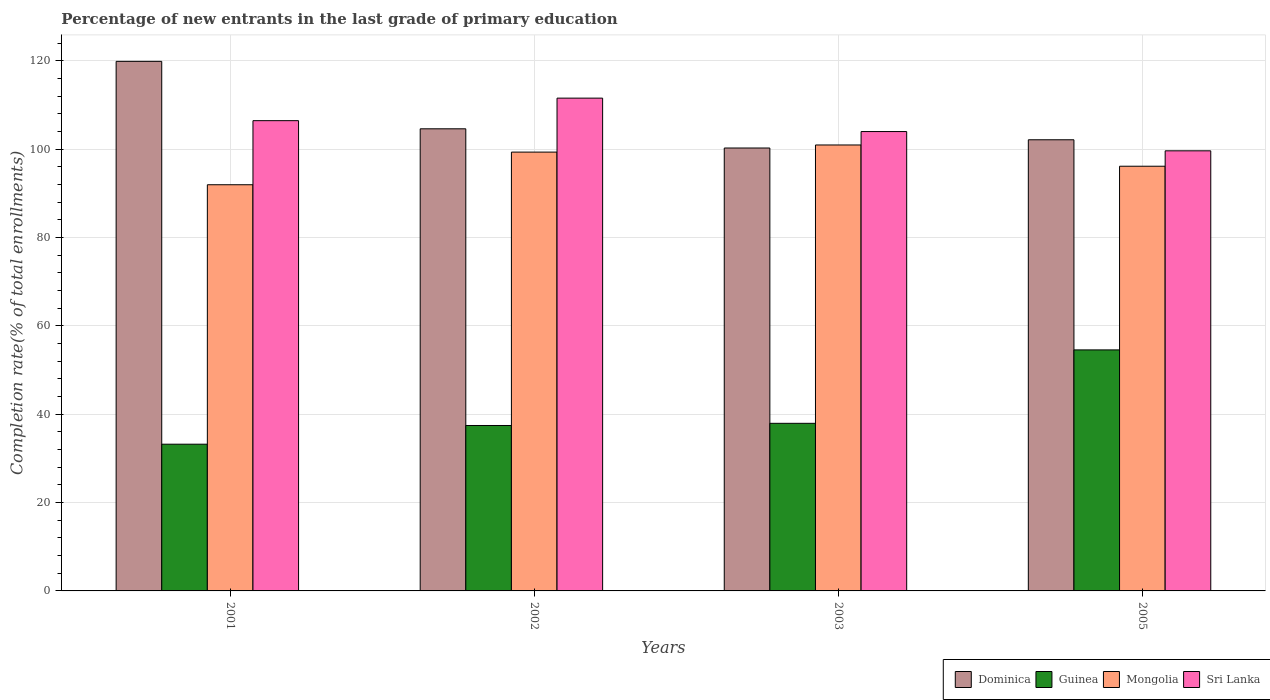How many groups of bars are there?
Offer a very short reply. 4. Are the number of bars on each tick of the X-axis equal?
Provide a succinct answer. Yes. In how many cases, is the number of bars for a given year not equal to the number of legend labels?
Your response must be concise. 0. What is the percentage of new entrants in Sri Lanka in 2002?
Provide a succinct answer. 111.57. Across all years, what is the maximum percentage of new entrants in Sri Lanka?
Offer a very short reply. 111.57. Across all years, what is the minimum percentage of new entrants in Mongolia?
Offer a very short reply. 91.96. In which year was the percentage of new entrants in Sri Lanka minimum?
Your response must be concise. 2005. What is the total percentage of new entrants in Guinea in the graph?
Provide a succinct answer. 163.19. What is the difference between the percentage of new entrants in Guinea in 2003 and that in 2005?
Ensure brevity in your answer.  -16.62. What is the difference between the percentage of new entrants in Mongolia in 2003 and the percentage of new entrants in Dominica in 2001?
Keep it short and to the point. -18.93. What is the average percentage of new entrants in Guinea per year?
Your answer should be compact. 40.8. In the year 2003, what is the difference between the percentage of new entrants in Guinea and percentage of new entrants in Dominica?
Offer a terse response. -62.33. What is the ratio of the percentage of new entrants in Dominica in 2001 to that in 2003?
Offer a terse response. 1.2. Is the percentage of new entrants in Sri Lanka in 2001 less than that in 2005?
Make the answer very short. No. What is the difference between the highest and the second highest percentage of new entrants in Dominica?
Your response must be concise. 15.27. What is the difference between the highest and the lowest percentage of new entrants in Sri Lanka?
Offer a very short reply. 11.93. Is the sum of the percentage of new entrants in Sri Lanka in 2001 and 2002 greater than the maximum percentage of new entrants in Dominica across all years?
Offer a very short reply. Yes. Is it the case that in every year, the sum of the percentage of new entrants in Mongolia and percentage of new entrants in Sri Lanka is greater than the sum of percentage of new entrants in Guinea and percentage of new entrants in Dominica?
Make the answer very short. No. What does the 2nd bar from the left in 2001 represents?
Keep it short and to the point. Guinea. What does the 2nd bar from the right in 2001 represents?
Your answer should be very brief. Mongolia. How many years are there in the graph?
Offer a terse response. 4. Are the values on the major ticks of Y-axis written in scientific E-notation?
Your response must be concise. No. Does the graph contain any zero values?
Provide a succinct answer. No. Where does the legend appear in the graph?
Make the answer very short. Bottom right. How many legend labels are there?
Your answer should be compact. 4. How are the legend labels stacked?
Offer a very short reply. Horizontal. What is the title of the graph?
Offer a terse response. Percentage of new entrants in the last grade of primary education. What is the label or title of the Y-axis?
Ensure brevity in your answer.  Completion rate(% of total enrollments). What is the Completion rate(% of total enrollments) in Dominica in 2001?
Provide a short and direct response. 119.9. What is the Completion rate(% of total enrollments) in Guinea in 2001?
Offer a very short reply. 33.22. What is the Completion rate(% of total enrollments) of Mongolia in 2001?
Your answer should be compact. 91.96. What is the Completion rate(% of total enrollments) of Sri Lanka in 2001?
Your answer should be compact. 106.47. What is the Completion rate(% of total enrollments) of Dominica in 2002?
Provide a short and direct response. 104.63. What is the Completion rate(% of total enrollments) in Guinea in 2002?
Offer a very short reply. 37.46. What is the Completion rate(% of total enrollments) in Mongolia in 2002?
Provide a succinct answer. 99.35. What is the Completion rate(% of total enrollments) of Sri Lanka in 2002?
Make the answer very short. 111.57. What is the Completion rate(% of total enrollments) of Dominica in 2003?
Your response must be concise. 100.28. What is the Completion rate(% of total enrollments) of Guinea in 2003?
Provide a succinct answer. 37.94. What is the Completion rate(% of total enrollments) in Mongolia in 2003?
Keep it short and to the point. 100.96. What is the Completion rate(% of total enrollments) of Sri Lanka in 2003?
Keep it short and to the point. 104. What is the Completion rate(% of total enrollments) in Dominica in 2005?
Your answer should be compact. 102.14. What is the Completion rate(% of total enrollments) in Guinea in 2005?
Provide a succinct answer. 54.57. What is the Completion rate(% of total enrollments) of Mongolia in 2005?
Keep it short and to the point. 96.15. What is the Completion rate(% of total enrollments) in Sri Lanka in 2005?
Offer a very short reply. 99.64. Across all years, what is the maximum Completion rate(% of total enrollments) in Dominica?
Your answer should be very brief. 119.9. Across all years, what is the maximum Completion rate(% of total enrollments) in Guinea?
Provide a succinct answer. 54.57. Across all years, what is the maximum Completion rate(% of total enrollments) of Mongolia?
Offer a very short reply. 100.96. Across all years, what is the maximum Completion rate(% of total enrollments) in Sri Lanka?
Provide a succinct answer. 111.57. Across all years, what is the minimum Completion rate(% of total enrollments) in Dominica?
Make the answer very short. 100.28. Across all years, what is the minimum Completion rate(% of total enrollments) of Guinea?
Offer a very short reply. 33.22. Across all years, what is the minimum Completion rate(% of total enrollments) of Mongolia?
Keep it short and to the point. 91.96. Across all years, what is the minimum Completion rate(% of total enrollments) of Sri Lanka?
Make the answer very short. 99.64. What is the total Completion rate(% of total enrollments) in Dominica in the graph?
Provide a succinct answer. 426.94. What is the total Completion rate(% of total enrollments) in Guinea in the graph?
Offer a terse response. 163.19. What is the total Completion rate(% of total enrollments) of Mongolia in the graph?
Provide a succinct answer. 388.43. What is the total Completion rate(% of total enrollments) of Sri Lanka in the graph?
Offer a very short reply. 421.68. What is the difference between the Completion rate(% of total enrollments) of Dominica in 2001 and that in 2002?
Your response must be concise. 15.27. What is the difference between the Completion rate(% of total enrollments) in Guinea in 2001 and that in 2002?
Provide a short and direct response. -4.23. What is the difference between the Completion rate(% of total enrollments) of Mongolia in 2001 and that in 2002?
Keep it short and to the point. -7.39. What is the difference between the Completion rate(% of total enrollments) of Sri Lanka in 2001 and that in 2002?
Offer a very short reply. -5.1. What is the difference between the Completion rate(% of total enrollments) of Dominica in 2001 and that in 2003?
Offer a terse response. 19.62. What is the difference between the Completion rate(% of total enrollments) of Guinea in 2001 and that in 2003?
Offer a very short reply. -4.72. What is the difference between the Completion rate(% of total enrollments) in Mongolia in 2001 and that in 2003?
Keep it short and to the point. -9. What is the difference between the Completion rate(% of total enrollments) in Sri Lanka in 2001 and that in 2003?
Offer a terse response. 2.47. What is the difference between the Completion rate(% of total enrollments) in Dominica in 2001 and that in 2005?
Give a very brief answer. 17.75. What is the difference between the Completion rate(% of total enrollments) in Guinea in 2001 and that in 2005?
Offer a very short reply. -21.35. What is the difference between the Completion rate(% of total enrollments) in Mongolia in 2001 and that in 2005?
Your answer should be compact. -4.19. What is the difference between the Completion rate(% of total enrollments) of Sri Lanka in 2001 and that in 2005?
Your answer should be very brief. 6.83. What is the difference between the Completion rate(% of total enrollments) of Dominica in 2002 and that in 2003?
Your answer should be compact. 4.35. What is the difference between the Completion rate(% of total enrollments) in Guinea in 2002 and that in 2003?
Offer a very short reply. -0.49. What is the difference between the Completion rate(% of total enrollments) in Mongolia in 2002 and that in 2003?
Your answer should be compact. -1.61. What is the difference between the Completion rate(% of total enrollments) in Sri Lanka in 2002 and that in 2003?
Your response must be concise. 7.57. What is the difference between the Completion rate(% of total enrollments) in Dominica in 2002 and that in 2005?
Give a very brief answer. 2.48. What is the difference between the Completion rate(% of total enrollments) in Guinea in 2002 and that in 2005?
Your answer should be very brief. -17.11. What is the difference between the Completion rate(% of total enrollments) in Mongolia in 2002 and that in 2005?
Your response must be concise. 3.2. What is the difference between the Completion rate(% of total enrollments) in Sri Lanka in 2002 and that in 2005?
Give a very brief answer. 11.93. What is the difference between the Completion rate(% of total enrollments) in Dominica in 2003 and that in 2005?
Make the answer very short. -1.86. What is the difference between the Completion rate(% of total enrollments) in Guinea in 2003 and that in 2005?
Your answer should be compact. -16.62. What is the difference between the Completion rate(% of total enrollments) in Mongolia in 2003 and that in 2005?
Provide a short and direct response. 4.81. What is the difference between the Completion rate(% of total enrollments) in Sri Lanka in 2003 and that in 2005?
Offer a very short reply. 4.36. What is the difference between the Completion rate(% of total enrollments) in Dominica in 2001 and the Completion rate(% of total enrollments) in Guinea in 2002?
Provide a short and direct response. 82.44. What is the difference between the Completion rate(% of total enrollments) in Dominica in 2001 and the Completion rate(% of total enrollments) in Mongolia in 2002?
Make the answer very short. 20.55. What is the difference between the Completion rate(% of total enrollments) in Dominica in 2001 and the Completion rate(% of total enrollments) in Sri Lanka in 2002?
Offer a very short reply. 8.33. What is the difference between the Completion rate(% of total enrollments) of Guinea in 2001 and the Completion rate(% of total enrollments) of Mongolia in 2002?
Offer a terse response. -66.13. What is the difference between the Completion rate(% of total enrollments) in Guinea in 2001 and the Completion rate(% of total enrollments) in Sri Lanka in 2002?
Offer a terse response. -78.35. What is the difference between the Completion rate(% of total enrollments) of Mongolia in 2001 and the Completion rate(% of total enrollments) of Sri Lanka in 2002?
Your answer should be very brief. -19.61. What is the difference between the Completion rate(% of total enrollments) in Dominica in 2001 and the Completion rate(% of total enrollments) in Guinea in 2003?
Your answer should be very brief. 81.95. What is the difference between the Completion rate(% of total enrollments) in Dominica in 2001 and the Completion rate(% of total enrollments) in Mongolia in 2003?
Offer a terse response. 18.93. What is the difference between the Completion rate(% of total enrollments) in Dominica in 2001 and the Completion rate(% of total enrollments) in Sri Lanka in 2003?
Provide a succinct answer. 15.89. What is the difference between the Completion rate(% of total enrollments) in Guinea in 2001 and the Completion rate(% of total enrollments) in Mongolia in 2003?
Ensure brevity in your answer.  -67.74. What is the difference between the Completion rate(% of total enrollments) of Guinea in 2001 and the Completion rate(% of total enrollments) of Sri Lanka in 2003?
Your response must be concise. -70.78. What is the difference between the Completion rate(% of total enrollments) in Mongolia in 2001 and the Completion rate(% of total enrollments) in Sri Lanka in 2003?
Your response must be concise. -12.04. What is the difference between the Completion rate(% of total enrollments) of Dominica in 2001 and the Completion rate(% of total enrollments) of Guinea in 2005?
Your answer should be compact. 65.33. What is the difference between the Completion rate(% of total enrollments) in Dominica in 2001 and the Completion rate(% of total enrollments) in Mongolia in 2005?
Offer a very short reply. 23.74. What is the difference between the Completion rate(% of total enrollments) in Dominica in 2001 and the Completion rate(% of total enrollments) in Sri Lanka in 2005?
Offer a very short reply. 20.26. What is the difference between the Completion rate(% of total enrollments) in Guinea in 2001 and the Completion rate(% of total enrollments) in Mongolia in 2005?
Make the answer very short. -62.93. What is the difference between the Completion rate(% of total enrollments) of Guinea in 2001 and the Completion rate(% of total enrollments) of Sri Lanka in 2005?
Your answer should be very brief. -66.42. What is the difference between the Completion rate(% of total enrollments) of Mongolia in 2001 and the Completion rate(% of total enrollments) of Sri Lanka in 2005?
Your answer should be very brief. -7.68. What is the difference between the Completion rate(% of total enrollments) of Dominica in 2002 and the Completion rate(% of total enrollments) of Guinea in 2003?
Your response must be concise. 66.68. What is the difference between the Completion rate(% of total enrollments) in Dominica in 2002 and the Completion rate(% of total enrollments) in Mongolia in 2003?
Offer a terse response. 3.66. What is the difference between the Completion rate(% of total enrollments) of Dominica in 2002 and the Completion rate(% of total enrollments) of Sri Lanka in 2003?
Make the answer very short. 0.62. What is the difference between the Completion rate(% of total enrollments) of Guinea in 2002 and the Completion rate(% of total enrollments) of Mongolia in 2003?
Your response must be concise. -63.51. What is the difference between the Completion rate(% of total enrollments) in Guinea in 2002 and the Completion rate(% of total enrollments) in Sri Lanka in 2003?
Offer a very short reply. -66.55. What is the difference between the Completion rate(% of total enrollments) in Mongolia in 2002 and the Completion rate(% of total enrollments) in Sri Lanka in 2003?
Your answer should be compact. -4.65. What is the difference between the Completion rate(% of total enrollments) in Dominica in 2002 and the Completion rate(% of total enrollments) in Guinea in 2005?
Provide a succinct answer. 50.06. What is the difference between the Completion rate(% of total enrollments) of Dominica in 2002 and the Completion rate(% of total enrollments) of Mongolia in 2005?
Keep it short and to the point. 8.47. What is the difference between the Completion rate(% of total enrollments) of Dominica in 2002 and the Completion rate(% of total enrollments) of Sri Lanka in 2005?
Your answer should be compact. 4.99. What is the difference between the Completion rate(% of total enrollments) in Guinea in 2002 and the Completion rate(% of total enrollments) in Mongolia in 2005?
Ensure brevity in your answer.  -58.7. What is the difference between the Completion rate(% of total enrollments) in Guinea in 2002 and the Completion rate(% of total enrollments) in Sri Lanka in 2005?
Your answer should be compact. -62.19. What is the difference between the Completion rate(% of total enrollments) of Mongolia in 2002 and the Completion rate(% of total enrollments) of Sri Lanka in 2005?
Your answer should be very brief. -0.29. What is the difference between the Completion rate(% of total enrollments) in Dominica in 2003 and the Completion rate(% of total enrollments) in Guinea in 2005?
Your response must be concise. 45.71. What is the difference between the Completion rate(% of total enrollments) of Dominica in 2003 and the Completion rate(% of total enrollments) of Mongolia in 2005?
Give a very brief answer. 4.12. What is the difference between the Completion rate(% of total enrollments) of Dominica in 2003 and the Completion rate(% of total enrollments) of Sri Lanka in 2005?
Offer a very short reply. 0.64. What is the difference between the Completion rate(% of total enrollments) in Guinea in 2003 and the Completion rate(% of total enrollments) in Mongolia in 2005?
Provide a succinct answer. -58.21. What is the difference between the Completion rate(% of total enrollments) in Guinea in 2003 and the Completion rate(% of total enrollments) in Sri Lanka in 2005?
Provide a succinct answer. -61.7. What is the difference between the Completion rate(% of total enrollments) of Mongolia in 2003 and the Completion rate(% of total enrollments) of Sri Lanka in 2005?
Your answer should be compact. 1.32. What is the average Completion rate(% of total enrollments) in Dominica per year?
Your answer should be compact. 106.74. What is the average Completion rate(% of total enrollments) in Guinea per year?
Your answer should be very brief. 40.8. What is the average Completion rate(% of total enrollments) in Mongolia per year?
Make the answer very short. 97.11. What is the average Completion rate(% of total enrollments) in Sri Lanka per year?
Make the answer very short. 105.42. In the year 2001, what is the difference between the Completion rate(% of total enrollments) of Dominica and Completion rate(% of total enrollments) of Guinea?
Make the answer very short. 86.68. In the year 2001, what is the difference between the Completion rate(% of total enrollments) of Dominica and Completion rate(% of total enrollments) of Mongolia?
Keep it short and to the point. 27.94. In the year 2001, what is the difference between the Completion rate(% of total enrollments) of Dominica and Completion rate(% of total enrollments) of Sri Lanka?
Your answer should be compact. 13.43. In the year 2001, what is the difference between the Completion rate(% of total enrollments) in Guinea and Completion rate(% of total enrollments) in Mongolia?
Ensure brevity in your answer.  -58.74. In the year 2001, what is the difference between the Completion rate(% of total enrollments) of Guinea and Completion rate(% of total enrollments) of Sri Lanka?
Your answer should be very brief. -73.25. In the year 2001, what is the difference between the Completion rate(% of total enrollments) in Mongolia and Completion rate(% of total enrollments) in Sri Lanka?
Offer a terse response. -14.51. In the year 2002, what is the difference between the Completion rate(% of total enrollments) in Dominica and Completion rate(% of total enrollments) in Guinea?
Ensure brevity in your answer.  67.17. In the year 2002, what is the difference between the Completion rate(% of total enrollments) in Dominica and Completion rate(% of total enrollments) in Mongolia?
Your answer should be very brief. 5.28. In the year 2002, what is the difference between the Completion rate(% of total enrollments) of Dominica and Completion rate(% of total enrollments) of Sri Lanka?
Make the answer very short. -6.94. In the year 2002, what is the difference between the Completion rate(% of total enrollments) in Guinea and Completion rate(% of total enrollments) in Mongolia?
Keep it short and to the point. -61.9. In the year 2002, what is the difference between the Completion rate(% of total enrollments) of Guinea and Completion rate(% of total enrollments) of Sri Lanka?
Your answer should be compact. -74.11. In the year 2002, what is the difference between the Completion rate(% of total enrollments) of Mongolia and Completion rate(% of total enrollments) of Sri Lanka?
Offer a terse response. -12.22. In the year 2003, what is the difference between the Completion rate(% of total enrollments) in Dominica and Completion rate(% of total enrollments) in Guinea?
Keep it short and to the point. 62.33. In the year 2003, what is the difference between the Completion rate(% of total enrollments) in Dominica and Completion rate(% of total enrollments) in Mongolia?
Make the answer very short. -0.69. In the year 2003, what is the difference between the Completion rate(% of total enrollments) in Dominica and Completion rate(% of total enrollments) in Sri Lanka?
Give a very brief answer. -3.72. In the year 2003, what is the difference between the Completion rate(% of total enrollments) of Guinea and Completion rate(% of total enrollments) of Mongolia?
Provide a succinct answer. -63.02. In the year 2003, what is the difference between the Completion rate(% of total enrollments) in Guinea and Completion rate(% of total enrollments) in Sri Lanka?
Your answer should be very brief. -66.06. In the year 2003, what is the difference between the Completion rate(% of total enrollments) of Mongolia and Completion rate(% of total enrollments) of Sri Lanka?
Provide a succinct answer. -3.04. In the year 2005, what is the difference between the Completion rate(% of total enrollments) in Dominica and Completion rate(% of total enrollments) in Guinea?
Your answer should be very brief. 47.57. In the year 2005, what is the difference between the Completion rate(% of total enrollments) in Dominica and Completion rate(% of total enrollments) in Mongolia?
Ensure brevity in your answer.  5.99. In the year 2005, what is the difference between the Completion rate(% of total enrollments) of Dominica and Completion rate(% of total enrollments) of Sri Lanka?
Your answer should be very brief. 2.5. In the year 2005, what is the difference between the Completion rate(% of total enrollments) of Guinea and Completion rate(% of total enrollments) of Mongolia?
Keep it short and to the point. -41.58. In the year 2005, what is the difference between the Completion rate(% of total enrollments) of Guinea and Completion rate(% of total enrollments) of Sri Lanka?
Your answer should be very brief. -45.07. In the year 2005, what is the difference between the Completion rate(% of total enrollments) in Mongolia and Completion rate(% of total enrollments) in Sri Lanka?
Provide a short and direct response. -3.49. What is the ratio of the Completion rate(% of total enrollments) in Dominica in 2001 to that in 2002?
Provide a short and direct response. 1.15. What is the ratio of the Completion rate(% of total enrollments) in Guinea in 2001 to that in 2002?
Your response must be concise. 0.89. What is the ratio of the Completion rate(% of total enrollments) of Mongolia in 2001 to that in 2002?
Ensure brevity in your answer.  0.93. What is the ratio of the Completion rate(% of total enrollments) in Sri Lanka in 2001 to that in 2002?
Give a very brief answer. 0.95. What is the ratio of the Completion rate(% of total enrollments) of Dominica in 2001 to that in 2003?
Give a very brief answer. 1.2. What is the ratio of the Completion rate(% of total enrollments) of Guinea in 2001 to that in 2003?
Keep it short and to the point. 0.88. What is the ratio of the Completion rate(% of total enrollments) in Mongolia in 2001 to that in 2003?
Your answer should be compact. 0.91. What is the ratio of the Completion rate(% of total enrollments) of Sri Lanka in 2001 to that in 2003?
Your answer should be very brief. 1.02. What is the ratio of the Completion rate(% of total enrollments) of Dominica in 2001 to that in 2005?
Provide a short and direct response. 1.17. What is the ratio of the Completion rate(% of total enrollments) in Guinea in 2001 to that in 2005?
Your response must be concise. 0.61. What is the ratio of the Completion rate(% of total enrollments) in Mongolia in 2001 to that in 2005?
Your answer should be compact. 0.96. What is the ratio of the Completion rate(% of total enrollments) in Sri Lanka in 2001 to that in 2005?
Your answer should be compact. 1.07. What is the ratio of the Completion rate(% of total enrollments) of Dominica in 2002 to that in 2003?
Your answer should be very brief. 1.04. What is the ratio of the Completion rate(% of total enrollments) in Guinea in 2002 to that in 2003?
Provide a succinct answer. 0.99. What is the ratio of the Completion rate(% of total enrollments) in Sri Lanka in 2002 to that in 2003?
Provide a short and direct response. 1.07. What is the ratio of the Completion rate(% of total enrollments) of Dominica in 2002 to that in 2005?
Your answer should be compact. 1.02. What is the ratio of the Completion rate(% of total enrollments) of Guinea in 2002 to that in 2005?
Make the answer very short. 0.69. What is the ratio of the Completion rate(% of total enrollments) in Sri Lanka in 2002 to that in 2005?
Provide a short and direct response. 1.12. What is the ratio of the Completion rate(% of total enrollments) of Dominica in 2003 to that in 2005?
Offer a very short reply. 0.98. What is the ratio of the Completion rate(% of total enrollments) in Guinea in 2003 to that in 2005?
Offer a terse response. 0.7. What is the ratio of the Completion rate(% of total enrollments) of Sri Lanka in 2003 to that in 2005?
Give a very brief answer. 1.04. What is the difference between the highest and the second highest Completion rate(% of total enrollments) of Dominica?
Provide a short and direct response. 15.27. What is the difference between the highest and the second highest Completion rate(% of total enrollments) in Guinea?
Your response must be concise. 16.62. What is the difference between the highest and the second highest Completion rate(% of total enrollments) in Mongolia?
Your answer should be very brief. 1.61. What is the difference between the highest and the second highest Completion rate(% of total enrollments) of Sri Lanka?
Give a very brief answer. 5.1. What is the difference between the highest and the lowest Completion rate(% of total enrollments) of Dominica?
Your response must be concise. 19.62. What is the difference between the highest and the lowest Completion rate(% of total enrollments) of Guinea?
Provide a short and direct response. 21.35. What is the difference between the highest and the lowest Completion rate(% of total enrollments) of Mongolia?
Your answer should be compact. 9. What is the difference between the highest and the lowest Completion rate(% of total enrollments) in Sri Lanka?
Give a very brief answer. 11.93. 